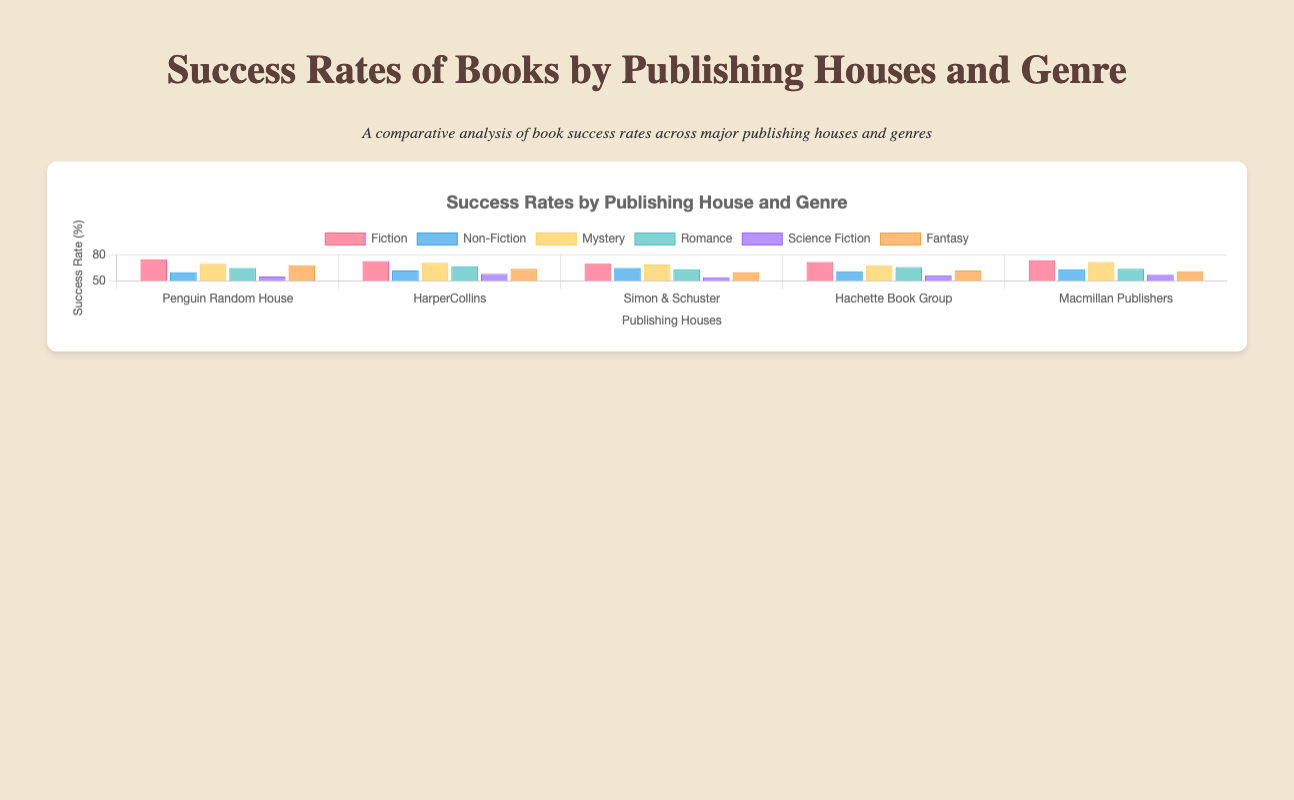What's the success rate of science fiction books published by Hachette Book Group? Locate the bar corresponding to "Hachette Book Group" for the "Science Fiction" genre. The success rate shown is 56%.
Answer: 56 Which publishing house has the highest success rate for fiction books? Compare the heights of the bars labeled "Fiction" for each publishing house. "Penguin Random House" has the highest bar for fiction at 75%.
Answer: Penguin Random House Which genre shows the smallest difference in success rates between Penguin Random House and Simon & Schuster? Calculate the difference in success rates for all genres between these two publishing houses. The smallest difference is for "Fantasy" (68 - 60 = 8).
Answer: Fantasy Overall, which publishing house has the most consistent success rates across all genres? Observe the vertical distribution of bars for each publishing house. "Hachette Book Group" shows relatively consistent success rates across genres, without extreme highs or lows.
Answer: Hachette Book Group What is the average success rate for mystery books across all publishing houses? Add the success rates for "Mystery" from all publishing houses: 70 + 71 + 69 + 68 + 72 = 350. Then divide by 5 (the number of publishing houses). The average is 350 / 5 = 70.
Answer: 70 Which publishing house has the lowest success rate for any genre, and what is that rate? Identify the shortest bar across all genres for each publishing house. The shortest bar is "Science Fiction" for Simon & Schuster at 54%.
Answer: Simon & Schuster, 54 Does HarperCollins have higher success rates in romance compared to science fiction? Compare the bar heights for the "Romance" and "Science Fiction" genres under HarperCollins. "Romance" is higher at 67%, while "Science Fiction" is 58%.
Answer: Yes Which genre seems to be the most successful overall across all publishing houses? Look at the aggregate heights of the bars for each genre. "Fiction" consistently shows higher success rates across all publishing houses.
Answer: Fiction For Penguin Random House, what's the difference in success rates between non-fiction and fantasy? Locate the bars for "Non-Fiction" and "Fantasy" for Penguin Random House. The rates are 60% and 68%, respectively. Calculate the difference: 68 - 60 = 8.
Answer: 8 